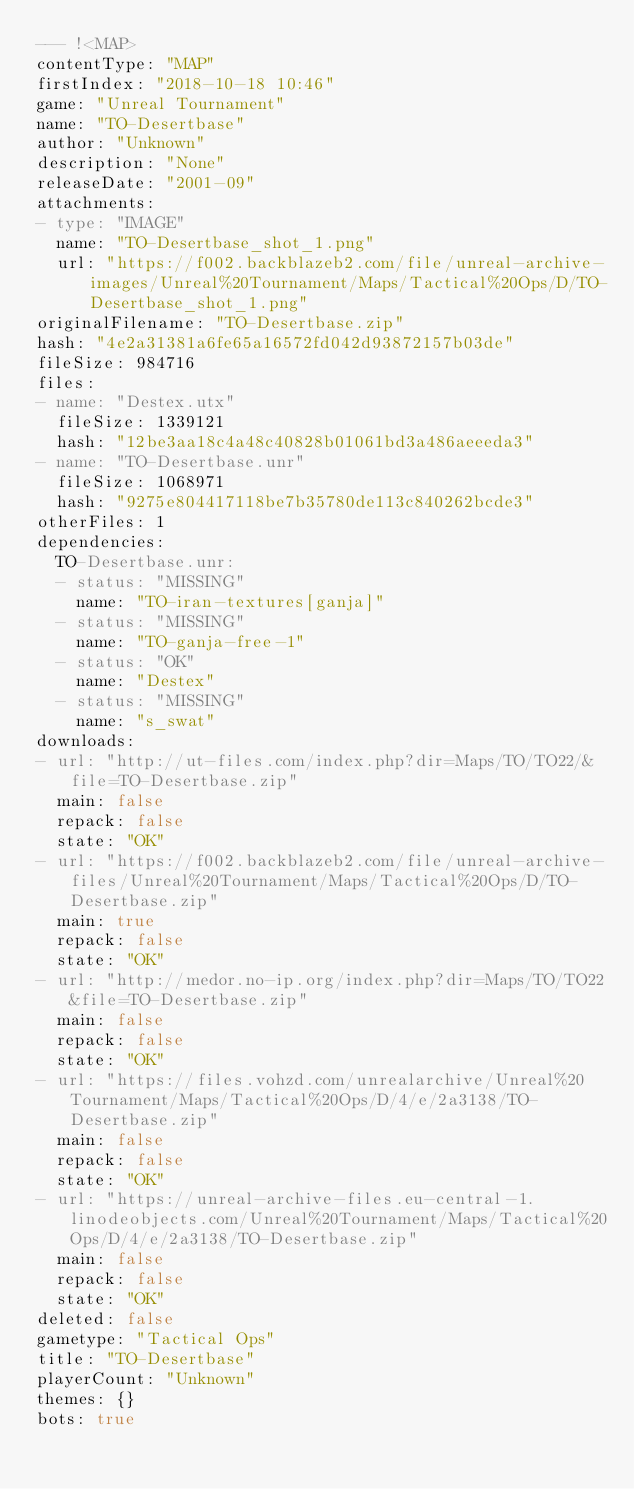<code> <loc_0><loc_0><loc_500><loc_500><_YAML_>--- !<MAP>
contentType: "MAP"
firstIndex: "2018-10-18 10:46"
game: "Unreal Tournament"
name: "TO-Desertbase"
author: "Unknown"
description: "None"
releaseDate: "2001-09"
attachments:
- type: "IMAGE"
  name: "TO-Desertbase_shot_1.png"
  url: "https://f002.backblazeb2.com/file/unreal-archive-images/Unreal%20Tournament/Maps/Tactical%20Ops/D/TO-Desertbase_shot_1.png"
originalFilename: "TO-Desertbase.zip"
hash: "4e2a31381a6fe65a16572fd042d93872157b03de"
fileSize: 984716
files:
- name: "Destex.utx"
  fileSize: 1339121
  hash: "12be3aa18c4a48c40828b01061bd3a486aeeeda3"
- name: "TO-Desertbase.unr"
  fileSize: 1068971
  hash: "9275e804417118be7b35780de113c840262bcde3"
otherFiles: 1
dependencies:
  TO-Desertbase.unr:
  - status: "MISSING"
    name: "TO-iran-textures[ganja]"
  - status: "MISSING"
    name: "TO-ganja-free-1"
  - status: "OK"
    name: "Destex"
  - status: "MISSING"
    name: "s_swat"
downloads:
- url: "http://ut-files.com/index.php?dir=Maps/TO/TO22/&file=TO-Desertbase.zip"
  main: false
  repack: false
  state: "OK"
- url: "https://f002.backblazeb2.com/file/unreal-archive-files/Unreal%20Tournament/Maps/Tactical%20Ops/D/TO-Desertbase.zip"
  main: true
  repack: false
  state: "OK"
- url: "http://medor.no-ip.org/index.php?dir=Maps/TO/TO22&file=TO-Desertbase.zip"
  main: false
  repack: false
  state: "OK"
- url: "https://files.vohzd.com/unrealarchive/Unreal%20Tournament/Maps/Tactical%20Ops/D/4/e/2a3138/TO-Desertbase.zip"
  main: false
  repack: false
  state: "OK"
- url: "https://unreal-archive-files.eu-central-1.linodeobjects.com/Unreal%20Tournament/Maps/Tactical%20Ops/D/4/e/2a3138/TO-Desertbase.zip"
  main: false
  repack: false
  state: "OK"
deleted: false
gametype: "Tactical Ops"
title: "TO-Desertbase"
playerCount: "Unknown"
themes: {}
bots: true
</code> 